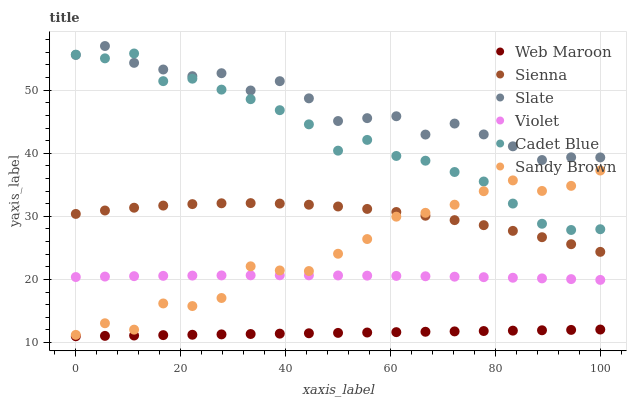Does Web Maroon have the minimum area under the curve?
Answer yes or no. Yes. Does Slate have the maximum area under the curve?
Answer yes or no. Yes. Does Slate have the minimum area under the curve?
Answer yes or no. No. Does Web Maroon have the maximum area under the curve?
Answer yes or no. No. Is Web Maroon the smoothest?
Answer yes or no. Yes. Is Sandy Brown the roughest?
Answer yes or no. Yes. Is Slate the smoothest?
Answer yes or no. No. Is Slate the roughest?
Answer yes or no. No. Does Web Maroon have the lowest value?
Answer yes or no. Yes. Does Slate have the lowest value?
Answer yes or no. No. Does Slate have the highest value?
Answer yes or no. Yes. Does Web Maroon have the highest value?
Answer yes or no. No. Is Sienna less than Cadet Blue?
Answer yes or no. Yes. Is Slate greater than Sienna?
Answer yes or no. Yes. Does Sandy Brown intersect Violet?
Answer yes or no. Yes. Is Sandy Brown less than Violet?
Answer yes or no. No. Is Sandy Brown greater than Violet?
Answer yes or no. No. Does Sienna intersect Cadet Blue?
Answer yes or no. No. 